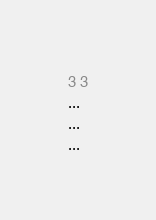Convert code to text. <code><loc_0><loc_0><loc_500><loc_500><_C++_>3 3
...
...
...</code> 